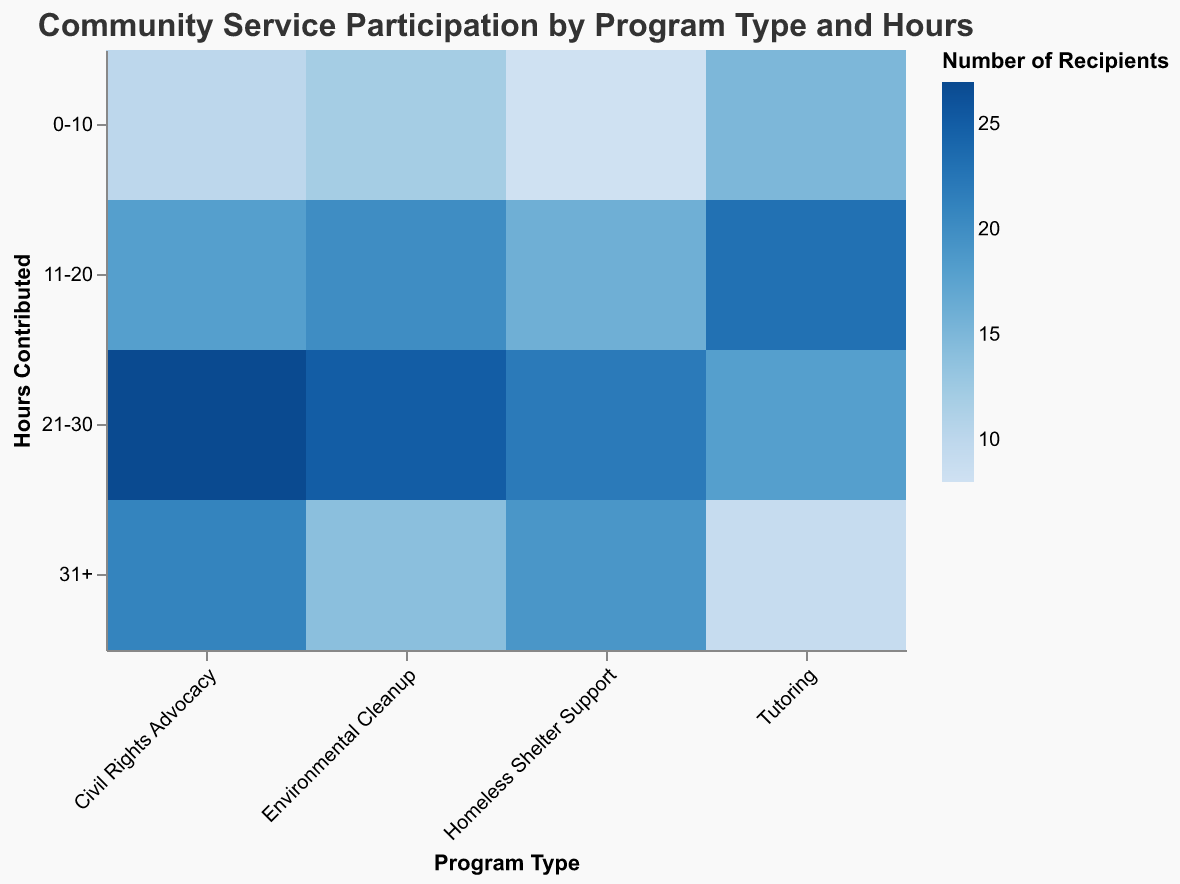What is the title of the mosaic plot? The title of the mosaic plot is usually displayed at the top of the figure in a larger or bold font. By looking at the figure, the title can be immediately identified.
Answer: Community Service Participation by Program Type and Hours How many scholarship recipients participated in the “Environmental Cleanup” program for 21-30 hours? To find this, locate the “Environmental Cleanup” program on the x-axis and the “21-30” hours on the y-axis, then identify the color indicating the number of recipients which corresponds to the legend.
Answer: 25 Which program type had the most scholarship recipients contributing more than 31 hours? To determine this, first find the program type on the x-axis, then check the "31+" section on the y-axis. Compare the colors of the respective sections to see which has the highest intensity according to the legend.
Answer: Civil Rights Advocacy By comparing “Tutoring” and “Homeless Shelter Support” programs, which had more participants in the 0-10 hours range? To find this, look at the “0-10” hours for both “Tutoring” and “Homeless Shelter Support” programs on the mosaic plot. Compare the colors or values indicated by the color intensity.
Answer: Tutoring What is the total number of scholarship recipients participating in community service for the 0-10 hours category across all programs? Sum the number of recipients in the "0-10" hours category for each program type: Tutoring (15) + Environmental Cleanup (12) + Homeless Shelter Support (8) + Civil Rights Advocacy (10) = 45.
Answer: 45 Are there more recipients in the “Civil Rights Advocacy” program that contributed 21-30 hours than those who contributed 0-20 hours in the same program? To determine this, you need to look at the Civil Rights Advocacy program and compare the color intensities: for 21-30 hours (27 recipients) and sum the numbers for 0-10 hours (10 recipients) and 11-20 hours (18 recipients), which gives 28 recipients.
Answer: No Which program has the smallest number of participants contributing more than 31 hours? Check the “31+” section on the y-axis and find the program with the least color intensity indicating the smallest number of participants.
Answer: Tutoring In which range of hours contributed by scholarship recipients does the “Environmental Cleanup” program have the highest number of participants? For the Environmental Cleanup program, find the range on the y-axis with the highest color intensity according to the legend.
Answer: 21-30 hours 